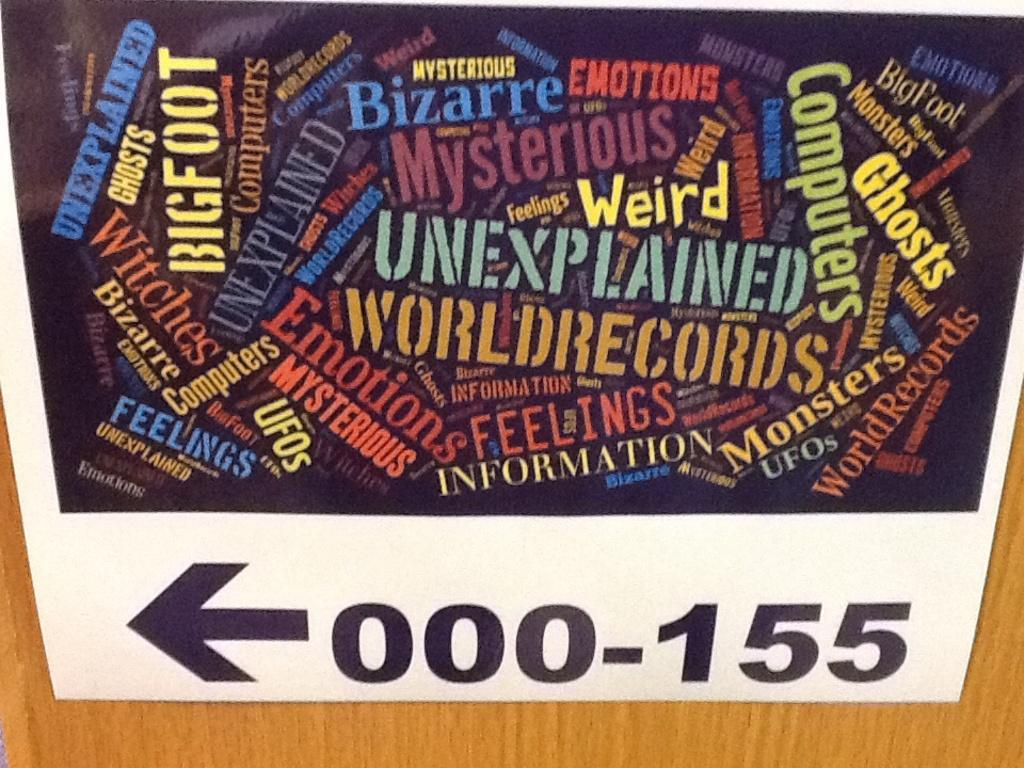<image>
Provide a brief description of the given image. A collage of words and colors with 000-155 below it. 